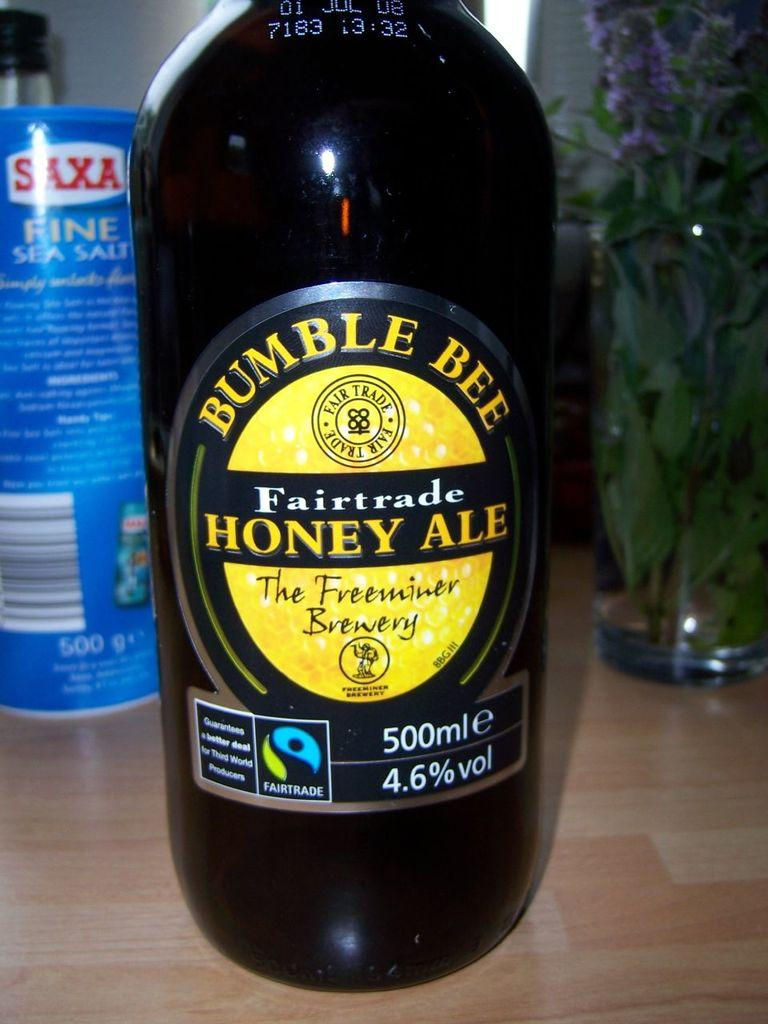<image>
Present a compact description of the photo's key features. A bottle of Bumble Bee Fairtrade Honey Ale. 